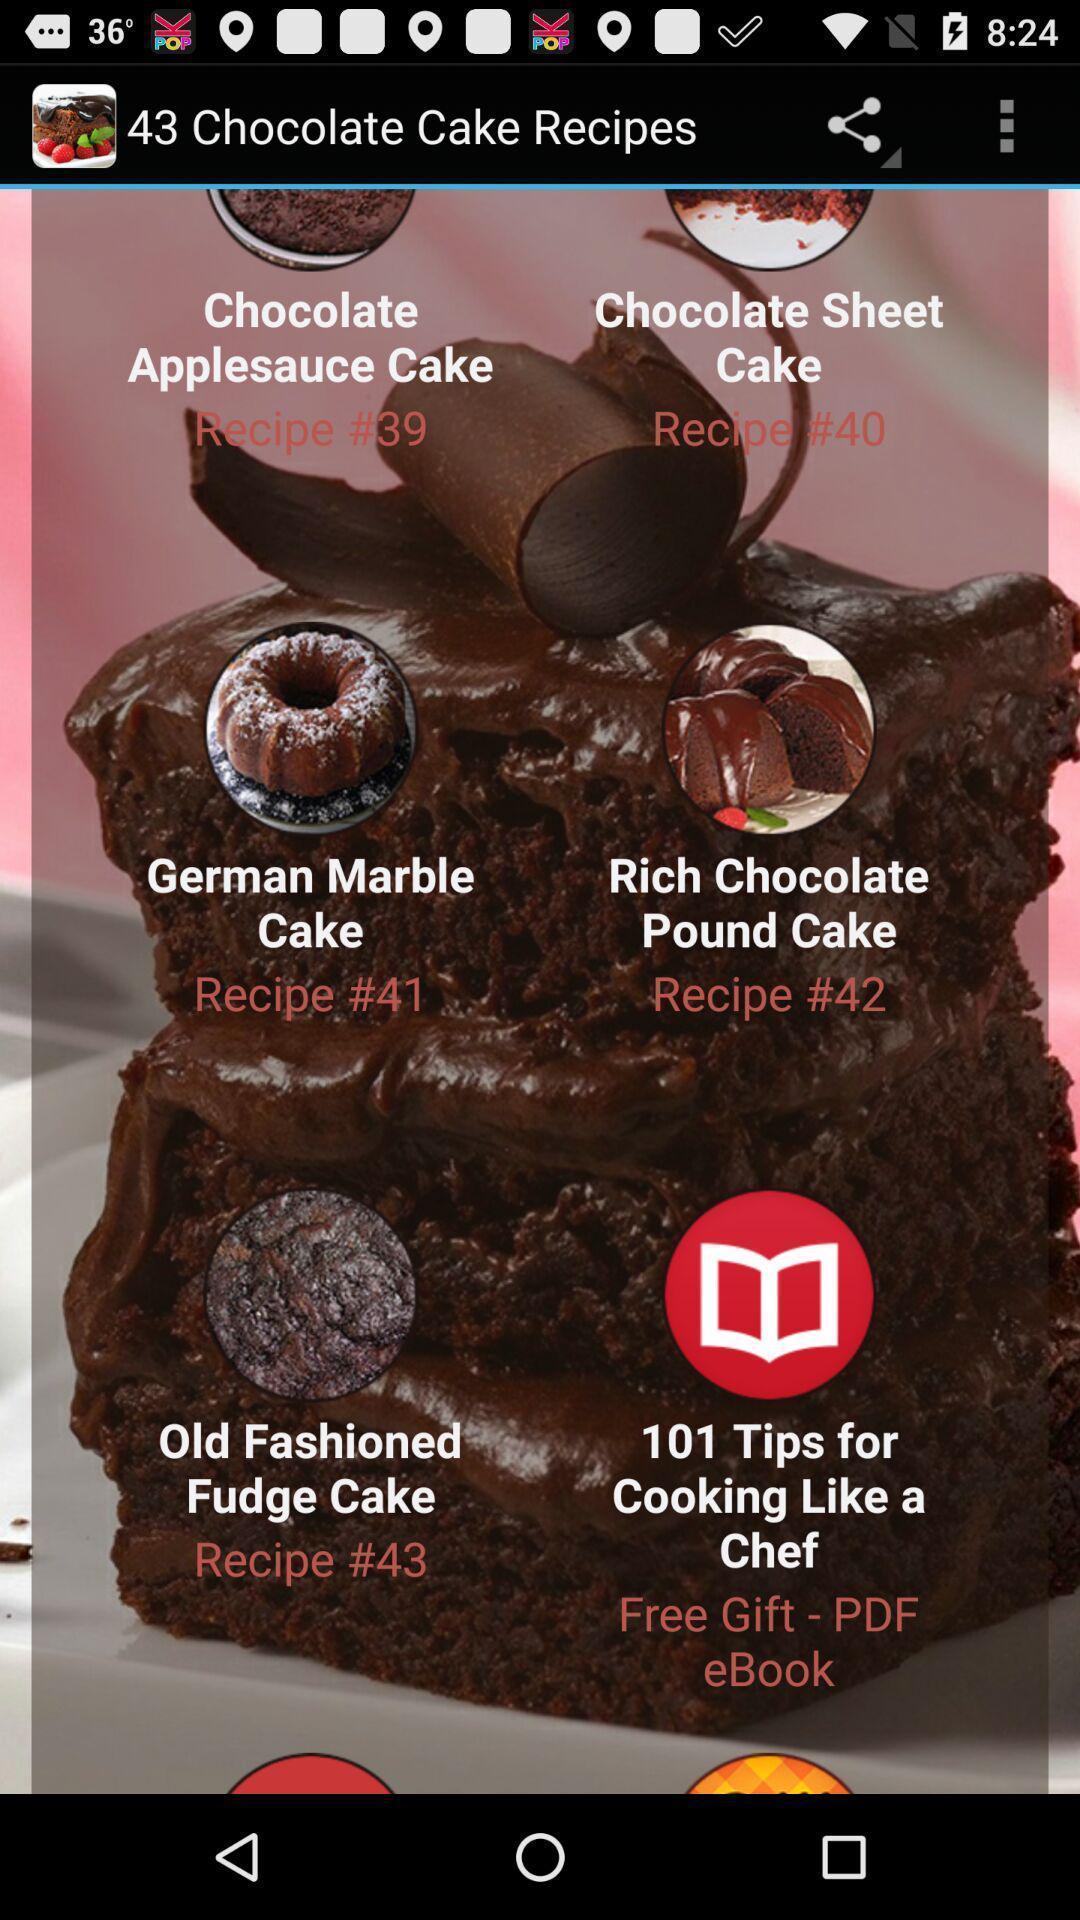Describe the key features of this screenshot. Various recipes in a cake preparing app. 